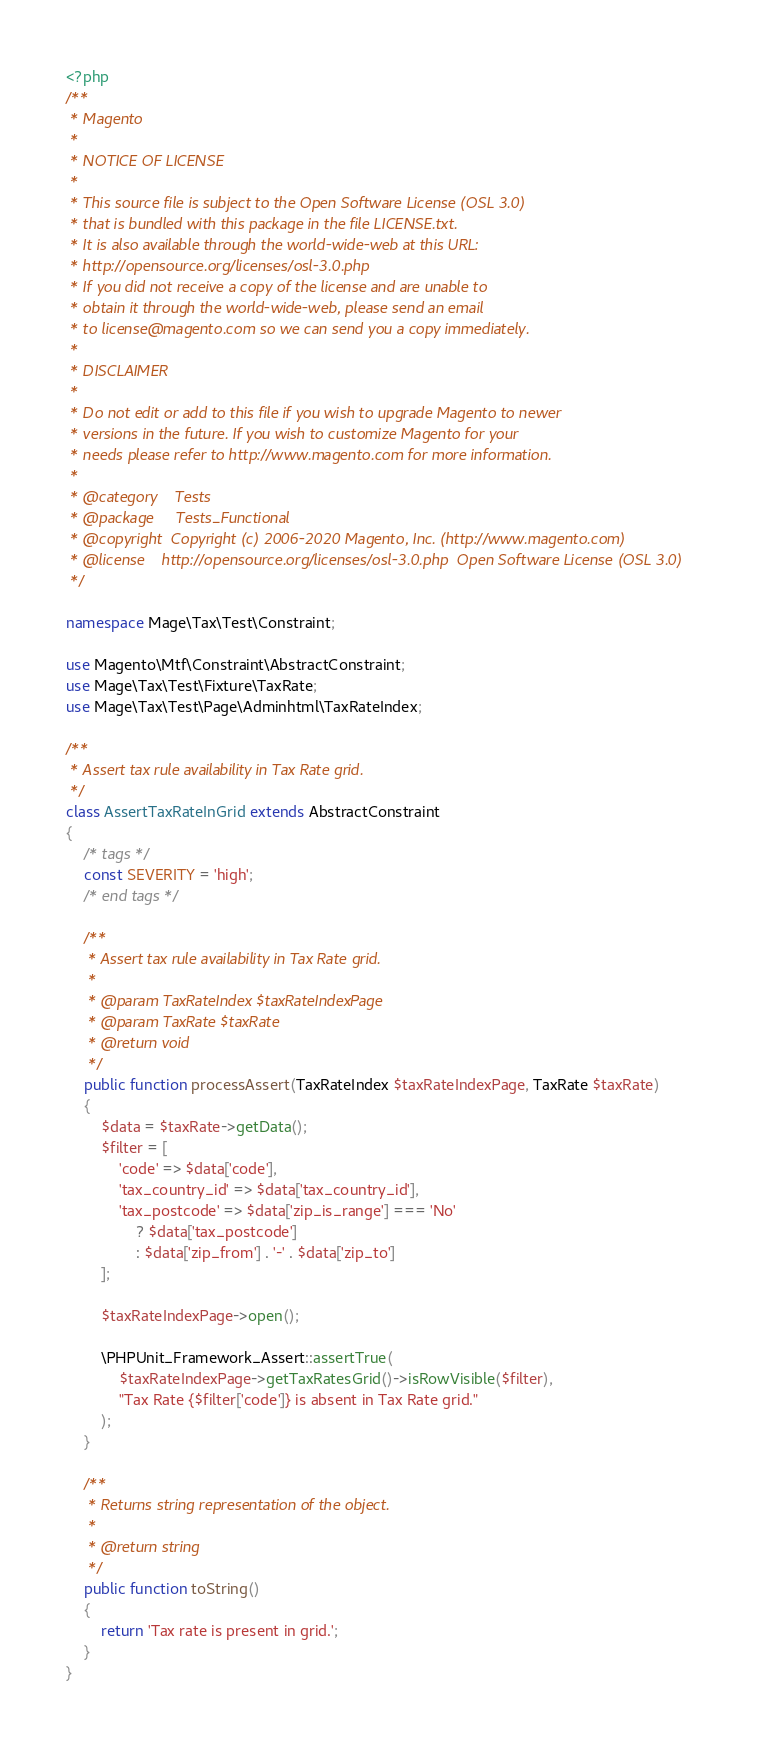<code> <loc_0><loc_0><loc_500><loc_500><_PHP_><?php
/**
 * Magento
 *
 * NOTICE OF LICENSE
 *
 * This source file is subject to the Open Software License (OSL 3.0)
 * that is bundled with this package in the file LICENSE.txt.
 * It is also available through the world-wide-web at this URL:
 * http://opensource.org/licenses/osl-3.0.php
 * If you did not receive a copy of the license and are unable to
 * obtain it through the world-wide-web, please send an email
 * to license@magento.com so we can send you a copy immediately.
 *
 * DISCLAIMER
 *
 * Do not edit or add to this file if you wish to upgrade Magento to newer
 * versions in the future. If you wish to customize Magento for your
 * needs please refer to http://www.magento.com for more information.
 *
 * @category    Tests
 * @package     Tests_Functional
 * @copyright  Copyright (c) 2006-2020 Magento, Inc. (http://www.magento.com)
 * @license    http://opensource.org/licenses/osl-3.0.php  Open Software License (OSL 3.0)
 */

namespace Mage\Tax\Test\Constraint;

use Magento\Mtf\Constraint\AbstractConstraint;
use Mage\Tax\Test\Fixture\TaxRate;
use Mage\Tax\Test\Page\Adminhtml\TaxRateIndex;

/**
 * Assert tax rule availability in Tax Rate grid.
 */
class AssertTaxRateInGrid extends AbstractConstraint
{
    /* tags */
    const SEVERITY = 'high';
    /* end tags */

    /**
     * Assert tax rule availability in Tax Rate grid.
     *
     * @param TaxRateIndex $taxRateIndexPage
     * @param TaxRate $taxRate
     * @return void
     */
    public function processAssert(TaxRateIndex $taxRateIndexPage, TaxRate $taxRate)
    {
        $data = $taxRate->getData();
        $filter = [
            'code' => $data['code'],
            'tax_country_id' => $data['tax_country_id'],
            'tax_postcode' => $data['zip_is_range'] === 'No'
                ? $data['tax_postcode']
                : $data['zip_from'] . '-' . $data['zip_to']
        ];

        $taxRateIndexPage->open();

        \PHPUnit_Framework_Assert::assertTrue(
            $taxRateIndexPage->getTaxRatesGrid()->isRowVisible($filter),
            "Tax Rate {$filter['code']} is absent in Tax Rate grid."
        );
    }

    /**
     * Returns string representation of the object.
     *
     * @return string
     */
    public function toString()
    {
        return 'Tax rate is present in grid.';
    }
}
</code> 